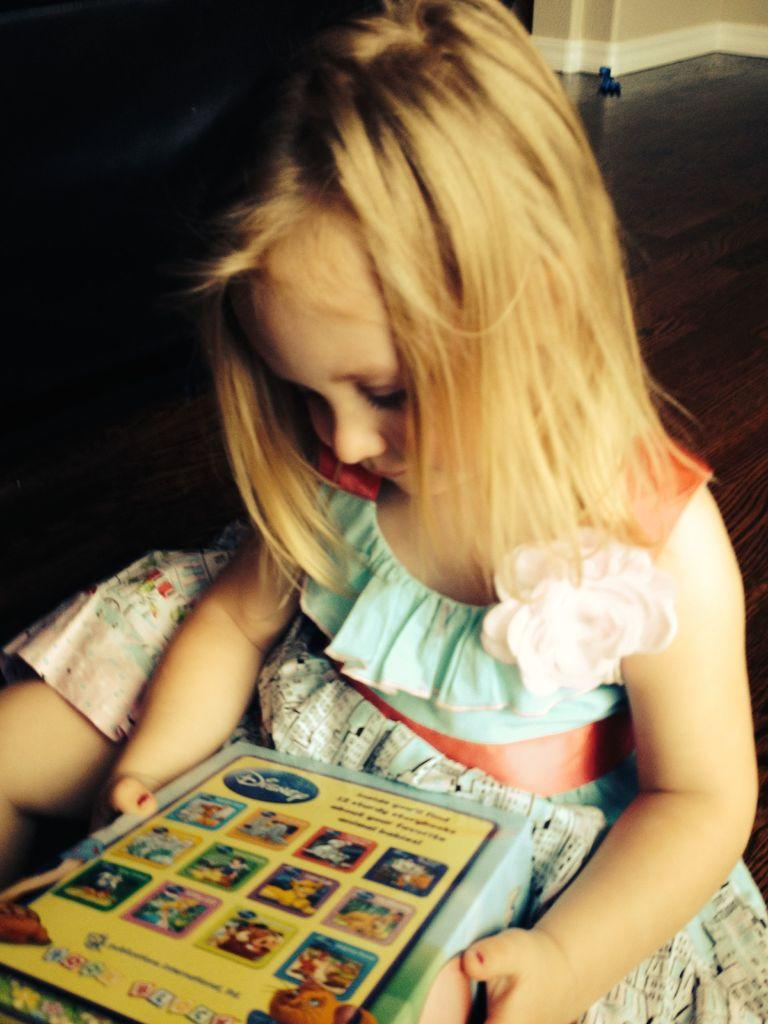What is the main subject of the image? The main subject of the image is a baby girl. What is the baby girl doing in the image? The baby girl is holding an object and sitting. What can be observed about the background of the image? The background of the image is dark. What degree does the baby girl have in the image? There is no indication of a degree in the image, as the subject is a baby girl. How does the baby girl react to the earthquake in the image? There is no earthquake present in the image, so the baby girl's reaction cannot be determined. 